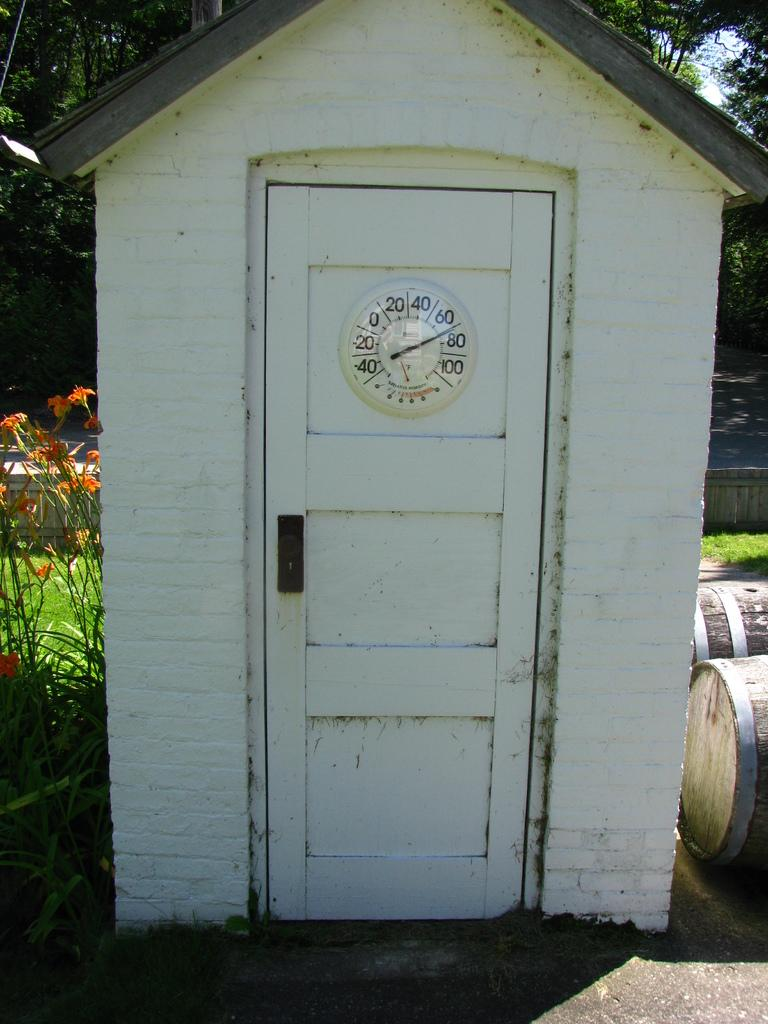<image>
Create a compact narrative representing the image presented. White door with a clock which has the hands in between the 60 and 80. 